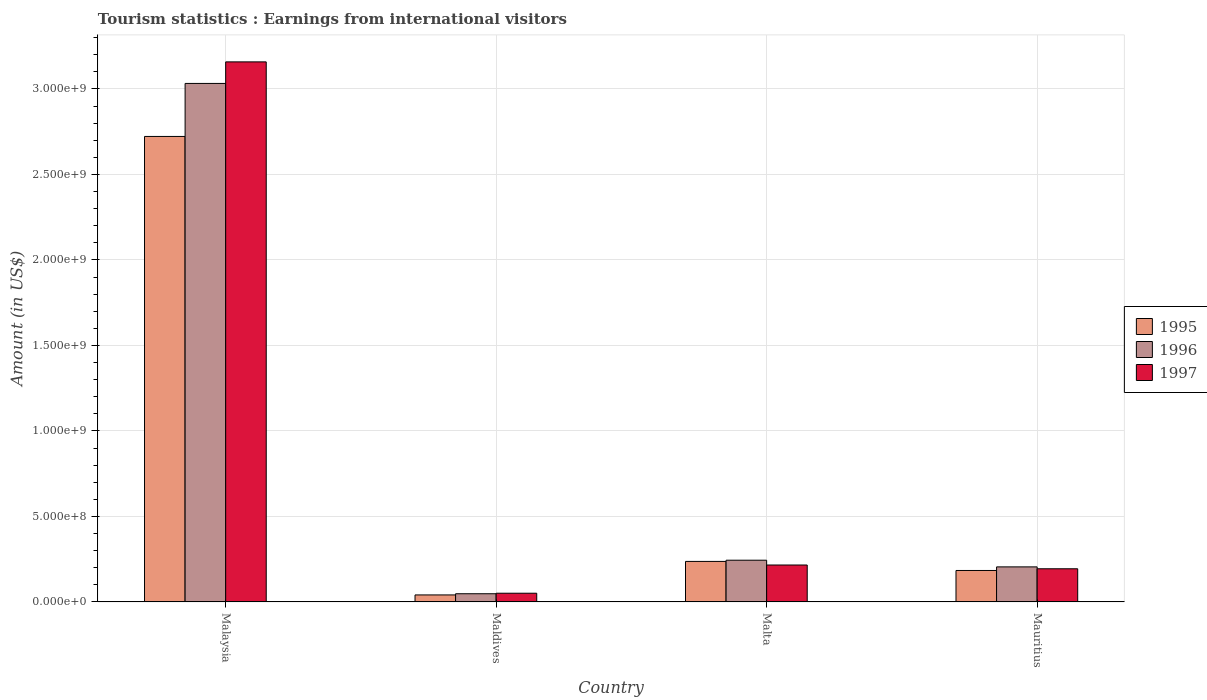How many groups of bars are there?
Keep it short and to the point. 4. Are the number of bars per tick equal to the number of legend labels?
Make the answer very short. Yes. How many bars are there on the 4th tick from the left?
Your answer should be compact. 3. What is the label of the 2nd group of bars from the left?
Your answer should be very brief. Maldives. What is the earnings from international visitors in 1997 in Malta?
Your response must be concise. 2.16e+08. Across all countries, what is the maximum earnings from international visitors in 1997?
Ensure brevity in your answer.  3.16e+09. Across all countries, what is the minimum earnings from international visitors in 1996?
Your response must be concise. 4.80e+07. In which country was the earnings from international visitors in 1995 maximum?
Your answer should be very brief. Malaysia. In which country was the earnings from international visitors in 1995 minimum?
Your answer should be very brief. Maldives. What is the total earnings from international visitors in 1997 in the graph?
Ensure brevity in your answer.  3.62e+09. What is the difference between the earnings from international visitors in 1996 in Malaysia and that in Malta?
Provide a short and direct response. 2.79e+09. What is the difference between the earnings from international visitors in 1997 in Malaysia and the earnings from international visitors in 1995 in Maldives?
Your answer should be compact. 3.12e+09. What is the average earnings from international visitors in 1996 per country?
Keep it short and to the point. 8.82e+08. What is the difference between the earnings from international visitors of/in 1997 and earnings from international visitors of/in 1996 in Malaysia?
Your answer should be very brief. 1.26e+08. What is the ratio of the earnings from international visitors in 1997 in Maldives to that in Mauritius?
Provide a succinct answer. 0.26. What is the difference between the highest and the second highest earnings from international visitors in 1995?
Your response must be concise. 2.54e+09. What is the difference between the highest and the lowest earnings from international visitors in 1996?
Your answer should be very brief. 2.98e+09. In how many countries, is the earnings from international visitors in 1996 greater than the average earnings from international visitors in 1996 taken over all countries?
Ensure brevity in your answer.  1. Is the sum of the earnings from international visitors in 1996 in Malaysia and Maldives greater than the maximum earnings from international visitors in 1995 across all countries?
Your answer should be compact. Yes. Is it the case that in every country, the sum of the earnings from international visitors in 1997 and earnings from international visitors in 1995 is greater than the earnings from international visitors in 1996?
Ensure brevity in your answer.  Yes. How many bars are there?
Give a very brief answer. 12. Are all the bars in the graph horizontal?
Keep it short and to the point. No. How many countries are there in the graph?
Give a very brief answer. 4. What is the difference between two consecutive major ticks on the Y-axis?
Give a very brief answer. 5.00e+08. Does the graph contain grids?
Offer a terse response. Yes. How many legend labels are there?
Your answer should be compact. 3. How are the legend labels stacked?
Provide a short and direct response. Vertical. What is the title of the graph?
Ensure brevity in your answer.  Tourism statistics : Earnings from international visitors. What is the label or title of the X-axis?
Your response must be concise. Country. What is the Amount (in US$) of 1995 in Malaysia?
Provide a succinct answer. 2.72e+09. What is the Amount (in US$) of 1996 in Malaysia?
Your answer should be very brief. 3.03e+09. What is the Amount (in US$) of 1997 in Malaysia?
Offer a very short reply. 3.16e+09. What is the Amount (in US$) in 1995 in Maldives?
Offer a terse response. 4.10e+07. What is the Amount (in US$) of 1996 in Maldives?
Your answer should be compact. 4.80e+07. What is the Amount (in US$) of 1997 in Maldives?
Your answer should be compact. 5.10e+07. What is the Amount (in US$) in 1995 in Malta?
Provide a short and direct response. 2.37e+08. What is the Amount (in US$) in 1996 in Malta?
Make the answer very short. 2.44e+08. What is the Amount (in US$) of 1997 in Malta?
Your answer should be very brief. 2.16e+08. What is the Amount (in US$) of 1995 in Mauritius?
Provide a succinct answer. 1.84e+08. What is the Amount (in US$) of 1996 in Mauritius?
Offer a terse response. 2.05e+08. What is the Amount (in US$) in 1997 in Mauritius?
Offer a terse response. 1.94e+08. Across all countries, what is the maximum Amount (in US$) of 1995?
Your answer should be compact. 2.72e+09. Across all countries, what is the maximum Amount (in US$) in 1996?
Make the answer very short. 3.03e+09. Across all countries, what is the maximum Amount (in US$) in 1997?
Give a very brief answer. 3.16e+09. Across all countries, what is the minimum Amount (in US$) in 1995?
Your response must be concise. 4.10e+07. Across all countries, what is the minimum Amount (in US$) in 1996?
Keep it short and to the point. 4.80e+07. Across all countries, what is the minimum Amount (in US$) in 1997?
Your answer should be compact. 5.10e+07. What is the total Amount (in US$) in 1995 in the graph?
Offer a very short reply. 3.18e+09. What is the total Amount (in US$) in 1996 in the graph?
Offer a terse response. 3.53e+09. What is the total Amount (in US$) of 1997 in the graph?
Keep it short and to the point. 3.62e+09. What is the difference between the Amount (in US$) of 1995 in Malaysia and that in Maldives?
Keep it short and to the point. 2.68e+09. What is the difference between the Amount (in US$) in 1996 in Malaysia and that in Maldives?
Your answer should be very brief. 2.98e+09. What is the difference between the Amount (in US$) in 1997 in Malaysia and that in Maldives?
Keep it short and to the point. 3.11e+09. What is the difference between the Amount (in US$) of 1995 in Malaysia and that in Malta?
Offer a very short reply. 2.48e+09. What is the difference between the Amount (in US$) in 1996 in Malaysia and that in Malta?
Provide a short and direct response. 2.79e+09. What is the difference between the Amount (in US$) of 1997 in Malaysia and that in Malta?
Your response must be concise. 2.94e+09. What is the difference between the Amount (in US$) in 1995 in Malaysia and that in Mauritius?
Your response must be concise. 2.54e+09. What is the difference between the Amount (in US$) in 1996 in Malaysia and that in Mauritius?
Make the answer very short. 2.83e+09. What is the difference between the Amount (in US$) in 1997 in Malaysia and that in Mauritius?
Your answer should be very brief. 2.96e+09. What is the difference between the Amount (in US$) of 1995 in Maldives and that in Malta?
Your answer should be very brief. -1.96e+08. What is the difference between the Amount (in US$) in 1996 in Maldives and that in Malta?
Your answer should be very brief. -1.96e+08. What is the difference between the Amount (in US$) in 1997 in Maldives and that in Malta?
Make the answer very short. -1.65e+08. What is the difference between the Amount (in US$) in 1995 in Maldives and that in Mauritius?
Your answer should be very brief. -1.43e+08. What is the difference between the Amount (in US$) of 1996 in Maldives and that in Mauritius?
Ensure brevity in your answer.  -1.57e+08. What is the difference between the Amount (in US$) of 1997 in Maldives and that in Mauritius?
Your answer should be very brief. -1.43e+08. What is the difference between the Amount (in US$) in 1995 in Malta and that in Mauritius?
Provide a short and direct response. 5.30e+07. What is the difference between the Amount (in US$) of 1996 in Malta and that in Mauritius?
Keep it short and to the point. 3.90e+07. What is the difference between the Amount (in US$) in 1997 in Malta and that in Mauritius?
Provide a short and direct response. 2.20e+07. What is the difference between the Amount (in US$) of 1995 in Malaysia and the Amount (in US$) of 1996 in Maldives?
Provide a short and direct response. 2.67e+09. What is the difference between the Amount (in US$) of 1995 in Malaysia and the Amount (in US$) of 1997 in Maldives?
Give a very brief answer. 2.67e+09. What is the difference between the Amount (in US$) in 1996 in Malaysia and the Amount (in US$) in 1997 in Maldives?
Give a very brief answer. 2.98e+09. What is the difference between the Amount (in US$) in 1995 in Malaysia and the Amount (in US$) in 1996 in Malta?
Offer a very short reply. 2.48e+09. What is the difference between the Amount (in US$) of 1995 in Malaysia and the Amount (in US$) of 1997 in Malta?
Offer a very short reply. 2.51e+09. What is the difference between the Amount (in US$) in 1996 in Malaysia and the Amount (in US$) in 1997 in Malta?
Your answer should be very brief. 2.82e+09. What is the difference between the Amount (in US$) in 1995 in Malaysia and the Amount (in US$) in 1996 in Mauritius?
Your answer should be very brief. 2.52e+09. What is the difference between the Amount (in US$) in 1995 in Malaysia and the Amount (in US$) in 1997 in Mauritius?
Ensure brevity in your answer.  2.53e+09. What is the difference between the Amount (in US$) of 1996 in Malaysia and the Amount (in US$) of 1997 in Mauritius?
Provide a short and direct response. 2.84e+09. What is the difference between the Amount (in US$) of 1995 in Maldives and the Amount (in US$) of 1996 in Malta?
Make the answer very short. -2.03e+08. What is the difference between the Amount (in US$) in 1995 in Maldives and the Amount (in US$) in 1997 in Malta?
Offer a very short reply. -1.75e+08. What is the difference between the Amount (in US$) in 1996 in Maldives and the Amount (in US$) in 1997 in Malta?
Provide a succinct answer. -1.68e+08. What is the difference between the Amount (in US$) of 1995 in Maldives and the Amount (in US$) of 1996 in Mauritius?
Provide a short and direct response. -1.64e+08. What is the difference between the Amount (in US$) in 1995 in Maldives and the Amount (in US$) in 1997 in Mauritius?
Provide a short and direct response. -1.53e+08. What is the difference between the Amount (in US$) in 1996 in Maldives and the Amount (in US$) in 1997 in Mauritius?
Your answer should be very brief. -1.46e+08. What is the difference between the Amount (in US$) in 1995 in Malta and the Amount (in US$) in 1996 in Mauritius?
Give a very brief answer. 3.20e+07. What is the difference between the Amount (in US$) in 1995 in Malta and the Amount (in US$) in 1997 in Mauritius?
Your answer should be very brief. 4.30e+07. What is the difference between the Amount (in US$) of 1996 in Malta and the Amount (in US$) of 1997 in Mauritius?
Provide a short and direct response. 5.00e+07. What is the average Amount (in US$) in 1995 per country?
Provide a short and direct response. 7.96e+08. What is the average Amount (in US$) in 1996 per country?
Your response must be concise. 8.82e+08. What is the average Amount (in US$) in 1997 per country?
Give a very brief answer. 9.05e+08. What is the difference between the Amount (in US$) in 1995 and Amount (in US$) in 1996 in Malaysia?
Provide a short and direct response. -3.10e+08. What is the difference between the Amount (in US$) in 1995 and Amount (in US$) in 1997 in Malaysia?
Your answer should be very brief. -4.36e+08. What is the difference between the Amount (in US$) of 1996 and Amount (in US$) of 1997 in Malaysia?
Your answer should be compact. -1.26e+08. What is the difference between the Amount (in US$) of 1995 and Amount (in US$) of 1996 in Maldives?
Provide a short and direct response. -7.00e+06. What is the difference between the Amount (in US$) in 1995 and Amount (in US$) in 1997 in Maldives?
Your answer should be compact. -1.00e+07. What is the difference between the Amount (in US$) of 1995 and Amount (in US$) of 1996 in Malta?
Ensure brevity in your answer.  -7.00e+06. What is the difference between the Amount (in US$) in 1995 and Amount (in US$) in 1997 in Malta?
Offer a terse response. 2.10e+07. What is the difference between the Amount (in US$) of 1996 and Amount (in US$) of 1997 in Malta?
Give a very brief answer. 2.80e+07. What is the difference between the Amount (in US$) of 1995 and Amount (in US$) of 1996 in Mauritius?
Offer a terse response. -2.10e+07. What is the difference between the Amount (in US$) in 1995 and Amount (in US$) in 1997 in Mauritius?
Ensure brevity in your answer.  -1.00e+07. What is the difference between the Amount (in US$) of 1996 and Amount (in US$) of 1997 in Mauritius?
Provide a succinct answer. 1.10e+07. What is the ratio of the Amount (in US$) in 1995 in Malaysia to that in Maldives?
Keep it short and to the point. 66.39. What is the ratio of the Amount (in US$) of 1996 in Malaysia to that in Maldives?
Keep it short and to the point. 63.17. What is the ratio of the Amount (in US$) of 1997 in Malaysia to that in Maldives?
Ensure brevity in your answer.  61.92. What is the ratio of the Amount (in US$) in 1995 in Malaysia to that in Malta?
Make the answer very short. 11.49. What is the ratio of the Amount (in US$) in 1996 in Malaysia to that in Malta?
Provide a short and direct response. 12.43. What is the ratio of the Amount (in US$) of 1997 in Malaysia to that in Malta?
Your answer should be very brief. 14.62. What is the ratio of the Amount (in US$) of 1995 in Malaysia to that in Mauritius?
Your response must be concise. 14.79. What is the ratio of the Amount (in US$) in 1996 in Malaysia to that in Mauritius?
Offer a very short reply. 14.79. What is the ratio of the Amount (in US$) of 1997 in Malaysia to that in Mauritius?
Provide a succinct answer. 16.28. What is the ratio of the Amount (in US$) in 1995 in Maldives to that in Malta?
Make the answer very short. 0.17. What is the ratio of the Amount (in US$) in 1996 in Maldives to that in Malta?
Keep it short and to the point. 0.2. What is the ratio of the Amount (in US$) of 1997 in Maldives to that in Malta?
Keep it short and to the point. 0.24. What is the ratio of the Amount (in US$) of 1995 in Maldives to that in Mauritius?
Ensure brevity in your answer.  0.22. What is the ratio of the Amount (in US$) of 1996 in Maldives to that in Mauritius?
Provide a succinct answer. 0.23. What is the ratio of the Amount (in US$) in 1997 in Maldives to that in Mauritius?
Your answer should be compact. 0.26. What is the ratio of the Amount (in US$) of 1995 in Malta to that in Mauritius?
Your response must be concise. 1.29. What is the ratio of the Amount (in US$) in 1996 in Malta to that in Mauritius?
Provide a short and direct response. 1.19. What is the ratio of the Amount (in US$) in 1997 in Malta to that in Mauritius?
Your answer should be very brief. 1.11. What is the difference between the highest and the second highest Amount (in US$) in 1995?
Make the answer very short. 2.48e+09. What is the difference between the highest and the second highest Amount (in US$) of 1996?
Your answer should be very brief. 2.79e+09. What is the difference between the highest and the second highest Amount (in US$) in 1997?
Offer a very short reply. 2.94e+09. What is the difference between the highest and the lowest Amount (in US$) in 1995?
Make the answer very short. 2.68e+09. What is the difference between the highest and the lowest Amount (in US$) of 1996?
Provide a succinct answer. 2.98e+09. What is the difference between the highest and the lowest Amount (in US$) in 1997?
Make the answer very short. 3.11e+09. 